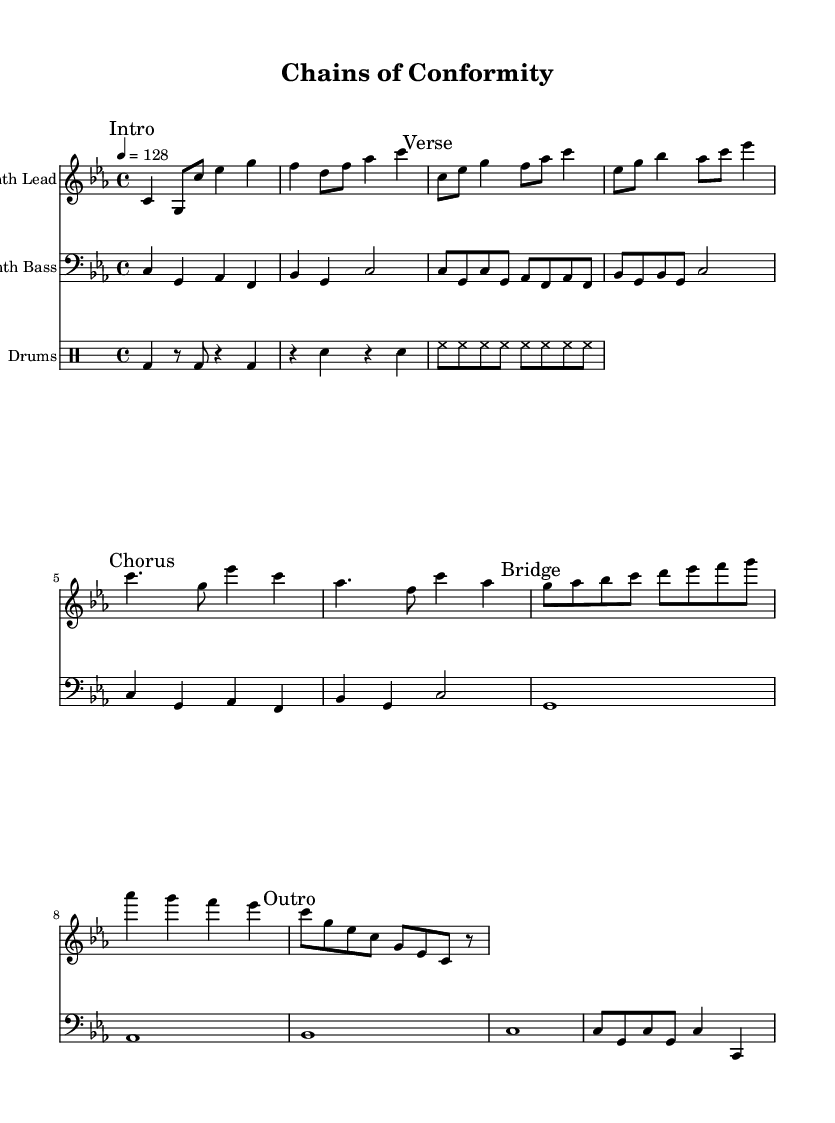What is the key signature of this music? The key signature is indicated at the beginning of the sheet music, showing C minor, which has three flat notes (B, E, and A).
Answer: C minor What is the time signature of this music? The time signature is shown at the beginning of the score as 4/4, meaning there are four beats in each measure and the quarter note gets the beat.
Answer: 4/4 What is the tempo of this music? The tempo marking at the beginning indicates that the music should be played at a speed of 128 beats per minute, which is a common tempo for electronic music.
Answer: 128 How many sections are there in "Chains of Conformity"? There are five distinct sections indicated by the marks: Intro, Verse, Chorus, Bridge, and Outro. This organization is often used in electronic music to create structure.
Answer: Five Which instrument is indicated as "Synth Lead"? The "Synth Lead" is indicated at the beginning of the staff that contains the melodic material, specifically labeled in the instrument name setting.
Answer: Synth Lead What common musical element is used throughout the sections for the drums? In all sections, a basic drum pattern is utilized, characterized by the presence of bass drum, snare, and hi-hat with consistent rhythmic structure that provides a driving force typical in electronic music.
Answer: Basic drum pattern Which note serves as the starting note in the Intro? The first note of the "Intro" section is C, played in the Synth Lead line. This sets the tonal center of the piece from the very beginning.
Answer: C 